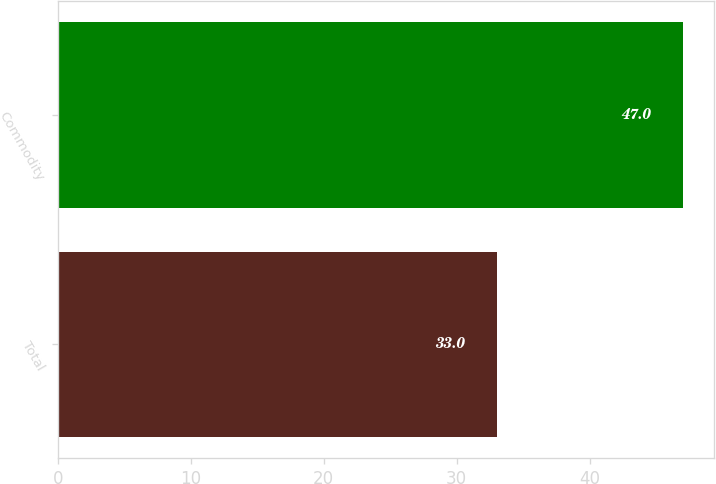<chart> <loc_0><loc_0><loc_500><loc_500><bar_chart><fcel>Total<fcel>Commodity<nl><fcel>33<fcel>47<nl></chart> 